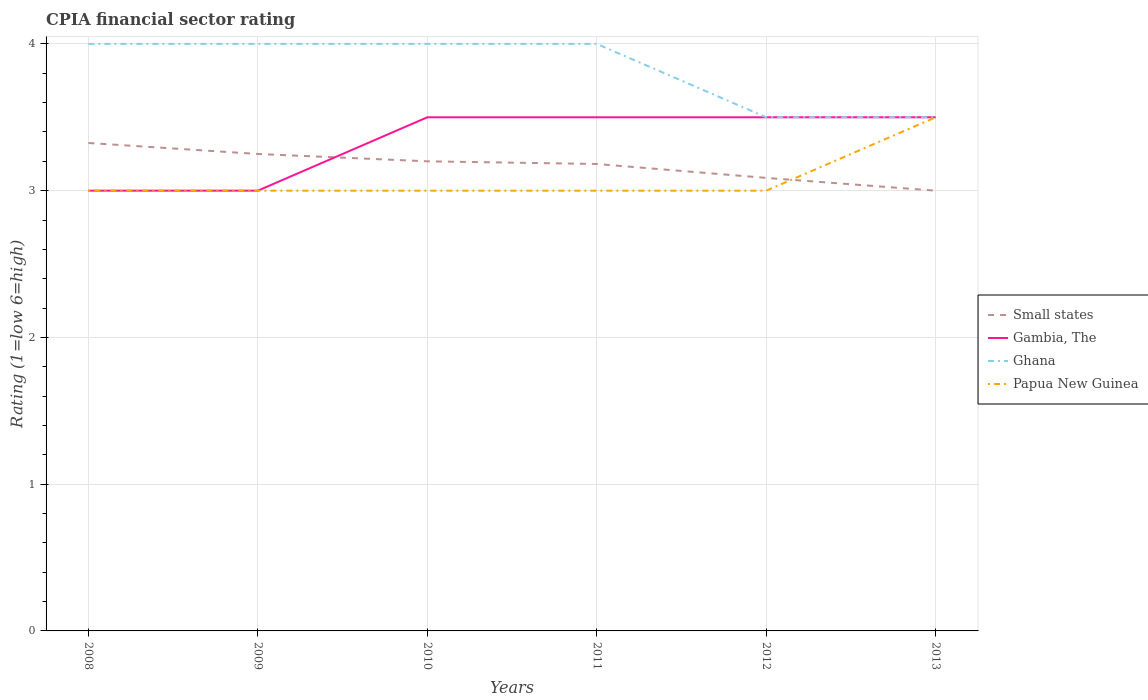Does the line corresponding to Small states intersect with the line corresponding to Gambia, The?
Offer a terse response. Yes. Across all years, what is the maximum CPIA rating in Ghana?
Your answer should be very brief. 3.5. In which year was the CPIA rating in Ghana maximum?
Your answer should be very brief. 2012. What is the difference between the highest and the second highest CPIA rating in Ghana?
Give a very brief answer. 0.5. How many lines are there?
Offer a terse response. 4. What is the difference between two consecutive major ticks on the Y-axis?
Provide a succinct answer. 1. Are the values on the major ticks of Y-axis written in scientific E-notation?
Ensure brevity in your answer.  No. Does the graph contain grids?
Provide a short and direct response. Yes. Where does the legend appear in the graph?
Make the answer very short. Center right. How many legend labels are there?
Make the answer very short. 4. How are the legend labels stacked?
Keep it short and to the point. Vertical. What is the title of the graph?
Offer a very short reply. CPIA financial sector rating. Does "Guam" appear as one of the legend labels in the graph?
Make the answer very short. No. What is the label or title of the X-axis?
Ensure brevity in your answer.  Years. What is the label or title of the Y-axis?
Your response must be concise. Rating (1=low 6=high). What is the Rating (1=low 6=high) of Small states in 2008?
Your answer should be compact. 3.33. What is the Rating (1=low 6=high) in Ghana in 2008?
Your answer should be compact. 4. What is the Rating (1=low 6=high) of Papua New Guinea in 2008?
Provide a succinct answer. 3. What is the Rating (1=low 6=high) of Small states in 2009?
Your answer should be very brief. 3.25. What is the Rating (1=low 6=high) in Papua New Guinea in 2009?
Make the answer very short. 3. What is the Rating (1=low 6=high) of Ghana in 2010?
Your response must be concise. 4. What is the Rating (1=low 6=high) of Papua New Guinea in 2010?
Keep it short and to the point. 3. What is the Rating (1=low 6=high) in Small states in 2011?
Give a very brief answer. 3.18. What is the Rating (1=low 6=high) of Ghana in 2011?
Provide a short and direct response. 4. What is the Rating (1=low 6=high) of Small states in 2012?
Make the answer very short. 3.09. What is the Rating (1=low 6=high) of Ghana in 2012?
Make the answer very short. 3.5. What is the Rating (1=low 6=high) of Small states in 2013?
Give a very brief answer. 3. What is the Rating (1=low 6=high) in Gambia, The in 2013?
Ensure brevity in your answer.  3.5. What is the Rating (1=low 6=high) of Ghana in 2013?
Ensure brevity in your answer.  3.5. What is the Rating (1=low 6=high) of Papua New Guinea in 2013?
Ensure brevity in your answer.  3.5. Across all years, what is the maximum Rating (1=low 6=high) of Small states?
Provide a succinct answer. 3.33. Across all years, what is the maximum Rating (1=low 6=high) of Gambia, The?
Keep it short and to the point. 3.5. Across all years, what is the maximum Rating (1=low 6=high) of Papua New Guinea?
Offer a terse response. 3.5. Across all years, what is the minimum Rating (1=low 6=high) in Gambia, The?
Offer a very short reply. 3. Across all years, what is the minimum Rating (1=low 6=high) of Ghana?
Provide a short and direct response. 3.5. What is the total Rating (1=low 6=high) of Small states in the graph?
Your answer should be compact. 19.04. What is the total Rating (1=low 6=high) of Papua New Guinea in the graph?
Offer a very short reply. 18.5. What is the difference between the Rating (1=low 6=high) in Small states in 2008 and that in 2009?
Provide a succinct answer. 0.07. What is the difference between the Rating (1=low 6=high) in Ghana in 2008 and that in 2009?
Keep it short and to the point. 0. What is the difference between the Rating (1=low 6=high) of Papua New Guinea in 2008 and that in 2009?
Provide a succinct answer. 0. What is the difference between the Rating (1=low 6=high) in Ghana in 2008 and that in 2010?
Provide a succinct answer. 0. What is the difference between the Rating (1=low 6=high) of Small states in 2008 and that in 2011?
Provide a succinct answer. 0.14. What is the difference between the Rating (1=low 6=high) in Gambia, The in 2008 and that in 2011?
Provide a short and direct response. -0.5. What is the difference between the Rating (1=low 6=high) of Small states in 2008 and that in 2012?
Your answer should be compact. 0.24. What is the difference between the Rating (1=low 6=high) of Gambia, The in 2008 and that in 2012?
Provide a succinct answer. -0.5. What is the difference between the Rating (1=low 6=high) in Small states in 2008 and that in 2013?
Keep it short and to the point. 0.33. What is the difference between the Rating (1=low 6=high) in Papua New Guinea in 2008 and that in 2013?
Offer a terse response. -0.5. What is the difference between the Rating (1=low 6=high) of Gambia, The in 2009 and that in 2010?
Make the answer very short. -0.5. What is the difference between the Rating (1=low 6=high) of Ghana in 2009 and that in 2010?
Ensure brevity in your answer.  0. What is the difference between the Rating (1=low 6=high) of Papua New Guinea in 2009 and that in 2010?
Your answer should be very brief. 0. What is the difference between the Rating (1=low 6=high) in Small states in 2009 and that in 2011?
Provide a succinct answer. 0.07. What is the difference between the Rating (1=low 6=high) in Gambia, The in 2009 and that in 2011?
Your answer should be compact. -0.5. What is the difference between the Rating (1=low 6=high) in Small states in 2009 and that in 2012?
Ensure brevity in your answer.  0.16. What is the difference between the Rating (1=low 6=high) in Gambia, The in 2009 and that in 2012?
Ensure brevity in your answer.  -0.5. What is the difference between the Rating (1=low 6=high) of Papua New Guinea in 2009 and that in 2012?
Your response must be concise. 0. What is the difference between the Rating (1=low 6=high) in Small states in 2009 and that in 2013?
Provide a short and direct response. 0.25. What is the difference between the Rating (1=low 6=high) in Ghana in 2009 and that in 2013?
Give a very brief answer. 0.5. What is the difference between the Rating (1=low 6=high) in Small states in 2010 and that in 2011?
Give a very brief answer. 0.02. What is the difference between the Rating (1=low 6=high) in Gambia, The in 2010 and that in 2011?
Your response must be concise. 0. What is the difference between the Rating (1=low 6=high) of Ghana in 2010 and that in 2011?
Your answer should be very brief. 0. What is the difference between the Rating (1=low 6=high) in Papua New Guinea in 2010 and that in 2011?
Give a very brief answer. 0. What is the difference between the Rating (1=low 6=high) of Small states in 2010 and that in 2012?
Provide a short and direct response. 0.11. What is the difference between the Rating (1=low 6=high) of Ghana in 2010 and that in 2012?
Offer a terse response. 0.5. What is the difference between the Rating (1=low 6=high) in Papua New Guinea in 2010 and that in 2012?
Your answer should be compact. 0. What is the difference between the Rating (1=low 6=high) in Ghana in 2010 and that in 2013?
Keep it short and to the point. 0.5. What is the difference between the Rating (1=low 6=high) in Papua New Guinea in 2010 and that in 2013?
Provide a succinct answer. -0.5. What is the difference between the Rating (1=low 6=high) of Small states in 2011 and that in 2012?
Keep it short and to the point. 0.09. What is the difference between the Rating (1=low 6=high) of Papua New Guinea in 2011 and that in 2012?
Your answer should be very brief. 0. What is the difference between the Rating (1=low 6=high) in Small states in 2011 and that in 2013?
Give a very brief answer. 0.18. What is the difference between the Rating (1=low 6=high) of Gambia, The in 2011 and that in 2013?
Your answer should be very brief. 0. What is the difference between the Rating (1=low 6=high) in Ghana in 2011 and that in 2013?
Your answer should be very brief. 0.5. What is the difference between the Rating (1=low 6=high) of Papua New Guinea in 2011 and that in 2013?
Give a very brief answer. -0.5. What is the difference between the Rating (1=low 6=high) in Small states in 2012 and that in 2013?
Give a very brief answer. 0.09. What is the difference between the Rating (1=low 6=high) in Ghana in 2012 and that in 2013?
Your response must be concise. 0. What is the difference between the Rating (1=low 6=high) of Small states in 2008 and the Rating (1=low 6=high) of Gambia, The in 2009?
Offer a very short reply. 0.33. What is the difference between the Rating (1=low 6=high) of Small states in 2008 and the Rating (1=low 6=high) of Ghana in 2009?
Your answer should be very brief. -0.68. What is the difference between the Rating (1=low 6=high) in Small states in 2008 and the Rating (1=low 6=high) in Papua New Guinea in 2009?
Make the answer very short. 0.33. What is the difference between the Rating (1=low 6=high) in Gambia, The in 2008 and the Rating (1=low 6=high) in Ghana in 2009?
Your answer should be compact. -1. What is the difference between the Rating (1=low 6=high) in Small states in 2008 and the Rating (1=low 6=high) in Gambia, The in 2010?
Keep it short and to the point. -0.17. What is the difference between the Rating (1=low 6=high) in Small states in 2008 and the Rating (1=low 6=high) in Ghana in 2010?
Provide a succinct answer. -0.68. What is the difference between the Rating (1=low 6=high) in Small states in 2008 and the Rating (1=low 6=high) in Papua New Guinea in 2010?
Your response must be concise. 0.33. What is the difference between the Rating (1=low 6=high) in Gambia, The in 2008 and the Rating (1=low 6=high) in Papua New Guinea in 2010?
Offer a very short reply. 0. What is the difference between the Rating (1=low 6=high) in Small states in 2008 and the Rating (1=low 6=high) in Gambia, The in 2011?
Your response must be concise. -0.17. What is the difference between the Rating (1=low 6=high) of Small states in 2008 and the Rating (1=low 6=high) of Ghana in 2011?
Keep it short and to the point. -0.68. What is the difference between the Rating (1=low 6=high) of Small states in 2008 and the Rating (1=low 6=high) of Papua New Guinea in 2011?
Keep it short and to the point. 0.33. What is the difference between the Rating (1=low 6=high) of Small states in 2008 and the Rating (1=low 6=high) of Gambia, The in 2012?
Your answer should be compact. -0.17. What is the difference between the Rating (1=low 6=high) in Small states in 2008 and the Rating (1=low 6=high) in Ghana in 2012?
Your response must be concise. -0.17. What is the difference between the Rating (1=low 6=high) of Small states in 2008 and the Rating (1=low 6=high) of Papua New Guinea in 2012?
Ensure brevity in your answer.  0.33. What is the difference between the Rating (1=low 6=high) of Gambia, The in 2008 and the Rating (1=low 6=high) of Ghana in 2012?
Your answer should be very brief. -0.5. What is the difference between the Rating (1=low 6=high) in Ghana in 2008 and the Rating (1=low 6=high) in Papua New Guinea in 2012?
Make the answer very short. 1. What is the difference between the Rating (1=low 6=high) in Small states in 2008 and the Rating (1=low 6=high) in Gambia, The in 2013?
Keep it short and to the point. -0.17. What is the difference between the Rating (1=low 6=high) of Small states in 2008 and the Rating (1=low 6=high) of Ghana in 2013?
Offer a terse response. -0.17. What is the difference between the Rating (1=low 6=high) in Small states in 2008 and the Rating (1=low 6=high) in Papua New Guinea in 2013?
Your answer should be compact. -0.17. What is the difference between the Rating (1=low 6=high) of Gambia, The in 2008 and the Rating (1=low 6=high) of Ghana in 2013?
Offer a very short reply. -0.5. What is the difference between the Rating (1=low 6=high) of Gambia, The in 2008 and the Rating (1=low 6=high) of Papua New Guinea in 2013?
Offer a very short reply. -0.5. What is the difference between the Rating (1=low 6=high) of Ghana in 2008 and the Rating (1=low 6=high) of Papua New Guinea in 2013?
Keep it short and to the point. 0.5. What is the difference between the Rating (1=low 6=high) in Small states in 2009 and the Rating (1=low 6=high) in Gambia, The in 2010?
Make the answer very short. -0.25. What is the difference between the Rating (1=low 6=high) in Small states in 2009 and the Rating (1=low 6=high) in Ghana in 2010?
Your answer should be very brief. -0.75. What is the difference between the Rating (1=low 6=high) of Gambia, The in 2009 and the Rating (1=low 6=high) of Ghana in 2010?
Provide a short and direct response. -1. What is the difference between the Rating (1=low 6=high) in Small states in 2009 and the Rating (1=low 6=high) in Gambia, The in 2011?
Give a very brief answer. -0.25. What is the difference between the Rating (1=low 6=high) in Small states in 2009 and the Rating (1=low 6=high) in Ghana in 2011?
Make the answer very short. -0.75. What is the difference between the Rating (1=low 6=high) of Gambia, The in 2009 and the Rating (1=low 6=high) of Papua New Guinea in 2011?
Make the answer very short. 0. What is the difference between the Rating (1=low 6=high) of Small states in 2009 and the Rating (1=low 6=high) of Gambia, The in 2012?
Offer a terse response. -0.25. What is the difference between the Rating (1=low 6=high) in Small states in 2009 and the Rating (1=low 6=high) in Ghana in 2012?
Provide a succinct answer. -0.25. What is the difference between the Rating (1=low 6=high) in Ghana in 2009 and the Rating (1=low 6=high) in Papua New Guinea in 2012?
Ensure brevity in your answer.  1. What is the difference between the Rating (1=low 6=high) of Small states in 2009 and the Rating (1=low 6=high) of Gambia, The in 2013?
Provide a succinct answer. -0.25. What is the difference between the Rating (1=low 6=high) of Small states in 2009 and the Rating (1=low 6=high) of Ghana in 2013?
Make the answer very short. -0.25. What is the difference between the Rating (1=low 6=high) in Gambia, The in 2009 and the Rating (1=low 6=high) in Ghana in 2013?
Keep it short and to the point. -0.5. What is the difference between the Rating (1=low 6=high) in Small states in 2010 and the Rating (1=low 6=high) in Ghana in 2011?
Make the answer very short. -0.8. What is the difference between the Rating (1=low 6=high) of Ghana in 2010 and the Rating (1=low 6=high) of Papua New Guinea in 2011?
Keep it short and to the point. 1. What is the difference between the Rating (1=low 6=high) in Small states in 2010 and the Rating (1=low 6=high) in Gambia, The in 2012?
Make the answer very short. -0.3. What is the difference between the Rating (1=low 6=high) of Gambia, The in 2010 and the Rating (1=low 6=high) of Papua New Guinea in 2012?
Make the answer very short. 0.5. What is the difference between the Rating (1=low 6=high) in Small states in 2010 and the Rating (1=low 6=high) in Gambia, The in 2013?
Provide a short and direct response. -0.3. What is the difference between the Rating (1=low 6=high) in Small states in 2010 and the Rating (1=low 6=high) in Papua New Guinea in 2013?
Offer a terse response. -0.3. What is the difference between the Rating (1=low 6=high) in Gambia, The in 2010 and the Rating (1=low 6=high) in Ghana in 2013?
Provide a short and direct response. 0. What is the difference between the Rating (1=low 6=high) in Small states in 2011 and the Rating (1=low 6=high) in Gambia, The in 2012?
Your answer should be very brief. -0.32. What is the difference between the Rating (1=low 6=high) of Small states in 2011 and the Rating (1=low 6=high) of Ghana in 2012?
Keep it short and to the point. -0.32. What is the difference between the Rating (1=low 6=high) in Small states in 2011 and the Rating (1=low 6=high) in Papua New Guinea in 2012?
Keep it short and to the point. 0.18. What is the difference between the Rating (1=low 6=high) in Gambia, The in 2011 and the Rating (1=low 6=high) in Ghana in 2012?
Your answer should be compact. 0. What is the difference between the Rating (1=low 6=high) of Ghana in 2011 and the Rating (1=low 6=high) of Papua New Guinea in 2012?
Your answer should be compact. 1. What is the difference between the Rating (1=low 6=high) of Small states in 2011 and the Rating (1=low 6=high) of Gambia, The in 2013?
Provide a short and direct response. -0.32. What is the difference between the Rating (1=low 6=high) in Small states in 2011 and the Rating (1=low 6=high) in Ghana in 2013?
Keep it short and to the point. -0.32. What is the difference between the Rating (1=low 6=high) of Small states in 2011 and the Rating (1=low 6=high) of Papua New Guinea in 2013?
Your answer should be compact. -0.32. What is the difference between the Rating (1=low 6=high) of Gambia, The in 2011 and the Rating (1=low 6=high) of Ghana in 2013?
Give a very brief answer. 0. What is the difference between the Rating (1=low 6=high) of Small states in 2012 and the Rating (1=low 6=high) of Gambia, The in 2013?
Make the answer very short. -0.41. What is the difference between the Rating (1=low 6=high) in Small states in 2012 and the Rating (1=low 6=high) in Ghana in 2013?
Provide a short and direct response. -0.41. What is the difference between the Rating (1=low 6=high) in Small states in 2012 and the Rating (1=low 6=high) in Papua New Guinea in 2013?
Your answer should be compact. -0.41. What is the difference between the Rating (1=low 6=high) of Ghana in 2012 and the Rating (1=low 6=high) of Papua New Guinea in 2013?
Offer a terse response. 0. What is the average Rating (1=low 6=high) in Small states per year?
Give a very brief answer. 3.17. What is the average Rating (1=low 6=high) in Gambia, The per year?
Your response must be concise. 3.33. What is the average Rating (1=low 6=high) of Ghana per year?
Your answer should be very brief. 3.83. What is the average Rating (1=low 6=high) in Papua New Guinea per year?
Provide a succinct answer. 3.08. In the year 2008, what is the difference between the Rating (1=low 6=high) of Small states and Rating (1=low 6=high) of Gambia, The?
Give a very brief answer. 0.33. In the year 2008, what is the difference between the Rating (1=low 6=high) in Small states and Rating (1=low 6=high) in Ghana?
Keep it short and to the point. -0.68. In the year 2008, what is the difference between the Rating (1=low 6=high) of Small states and Rating (1=low 6=high) of Papua New Guinea?
Keep it short and to the point. 0.33. In the year 2008, what is the difference between the Rating (1=low 6=high) of Gambia, The and Rating (1=low 6=high) of Ghana?
Your answer should be very brief. -1. In the year 2008, what is the difference between the Rating (1=low 6=high) of Ghana and Rating (1=low 6=high) of Papua New Guinea?
Provide a succinct answer. 1. In the year 2009, what is the difference between the Rating (1=low 6=high) in Small states and Rating (1=low 6=high) in Ghana?
Provide a short and direct response. -0.75. In the year 2009, what is the difference between the Rating (1=low 6=high) of Small states and Rating (1=low 6=high) of Papua New Guinea?
Provide a succinct answer. 0.25. In the year 2009, what is the difference between the Rating (1=low 6=high) in Gambia, The and Rating (1=low 6=high) in Papua New Guinea?
Your response must be concise. 0. In the year 2009, what is the difference between the Rating (1=low 6=high) of Ghana and Rating (1=low 6=high) of Papua New Guinea?
Make the answer very short. 1. In the year 2010, what is the difference between the Rating (1=low 6=high) in Small states and Rating (1=low 6=high) in Gambia, The?
Your answer should be compact. -0.3. In the year 2010, what is the difference between the Rating (1=low 6=high) of Small states and Rating (1=low 6=high) of Ghana?
Offer a terse response. -0.8. In the year 2010, what is the difference between the Rating (1=low 6=high) of Gambia, The and Rating (1=low 6=high) of Ghana?
Provide a succinct answer. -0.5. In the year 2010, what is the difference between the Rating (1=low 6=high) of Gambia, The and Rating (1=low 6=high) of Papua New Guinea?
Offer a terse response. 0.5. In the year 2011, what is the difference between the Rating (1=low 6=high) in Small states and Rating (1=low 6=high) in Gambia, The?
Give a very brief answer. -0.32. In the year 2011, what is the difference between the Rating (1=low 6=high) in Small states and Rating (1=low 6=high) in Ghana?
Your answer should be very brief. -0.82. In the year 2011, what is the difference between the Rating (1=low 6=high) in Small states and Rating (1=low 6=high) in Papua New Guinea?
Give a very brief answer. 0.18. In the year 2011, what is the difference between the Rating (1=low 6=high) of Gambia, The and Rating (1=low 6=high) of Ghana?
Provide a succinct answer. -0.5. In the year 2011, what is the difference between the Rating (1=low 6=high) of Gambia, The and Rating (1=low 6=high) of Papua New Guinea?
Your answer should be compact. 0.5. In the year 2012, what is the difference between the Rating (1=low 6=high) in Small states and Rating (1=low 6=high) in Gambia, The?
Keep it short and to the point. -0.41. In the year 2012, what is the difference between the Rating (1=low 6=high) in Small states and Rating (1=low 6=high) in Ghana?
Offer a terse response. -0.41. In the year 2012, what is the difference between the Rating (1=low 6=high) in Small states and Rating (1=low 6=high) in Papua New Guinea?
Your answer should be compact. 0.09. In the year 2012, what is the difference between the Rating (1=low 6=high) in Ghana and Rating (1=low 6=high) in Papua New Guinea?
Ensure brevity in your answer.  0.5. In the year 2013, what is the difference between the Rating (1=low 6=high) of Small states and Rating (1=low 6=high) of Papua New Guinea?
Provide a succinct answer. -0.5. In the year 2013, what is the difference between the Rating (1=low 6=high) of Ghana and Rating (1=low 6=high) of Papua New Guinea?
Make the answer very short. 0. What is the ratio of the Rating (1=low 6=high) of Small states in 2008 to that in 2009?
Offer a very short reply. 1.02. What is the ratio of the Rating (1=low 6=high) in Ghana in 2008 to that in 2009?
Provide a short and direct response. 1. What is the ratio of the Rating (1=low 6=high) in Papua New Guinea in 2008 to that in 2009?
Keep it short and to the point. 1. What is the ratio of the Rating (1=low 6=high) of Small states in 2008 to that in 2010?
Provide a short and direct response. 1.04. What is the ratio of the Rating (1=low 6=high) of Gambia, The in 2008 to that in 2010?
Keep it short and to the point. 0.86. What is the ratio of the Rating (1=low 6=high) in Ghana in 2008 to that in 2010?
Give a very brief answer. 1. What is the ratio of the Rating (1=low 6=high) of Papua New Guinea in 2008 to that in 2010?
Provide a short and direct response. 1. What is the ratio of the Rating (1=low 6=high) in Small states in 2008 to that in 2011?
Give a very brief answer. 1.04. What is the ratio of the Rating (1=low 6=high) of Gambia, The in 2008 to that in 2011?
Keep it short and to the point. 0.86. What is the ratio of the Rating (1=low 6=high) of Ghana in 2008 to that in 2011?
Offer a very short reply. 1. What is the ratio of the Rating (1=low 6=high) of Small states in 2008 to that in 2012?
Your answer should be compact. 1.08. What is the ratio of the Rating (1=low 6=high) in Gambia, The in 2008 to that in 2012?
Provide a succinct answer. 0.86. What is the ratio of the Rating (1=low 6=high) of Ghana in 2008 to that in 2012?
Your answer should be very brief. 1.14. What is the ratio of the Rating (1=low 6=high) of Papua New Guinea in 2008 to that in 2012?
Ensure brevity in your answer.  1. What is the ratio of the Rating (1=low 6=high) in Small states in 2008 to that in 2013?
Offer a terse response. 1.11. What is the ratio of the Rating (1=low 6=high) in Gambia, The in 2008 to that in 2013?
Make the answer very short. 0.86. What is the ratio of the Rating (1=low 6=high) in Ghana in 2008 to that in 2013?
Offer a very short reply. 1.14. What is the ratio of the Rating (1=low 6=high) in Papua New Guinea in 2008 to that in 2013?
Give a very brief answer. 0.86. What is the ratio of the Rating (1=low 6=high) in Small states in 2009 to that in 2010?
Ensure brevity in your answer.  1.02. What is the ratio of the Rating (1=low 6=high) of Gambia, The in 2009 to that in 2010?
Provide a short and direct response. 0.86. What is the ratio of the Rating (1=low 6=high) in Ghana in 2009 to that in 2010?
Your answer should be compact. 1. What is the ratio of the Rating (1=low 6=high) in Papua New Guinea in 2009 to that in 2010?
Your answer should be very brief. 1. What is the ratio of the Rating (1=low 6=high) in Small states in 2009 to that in 2011?
Ensure brevity in your answer.  1.02. What is the ratio of the Rating (1=low 6=high) in Gambia, The in 2009 to that in 2011?
Ensure brevity in your answer.  0.86. What is the ratio of the Rating (1=low 6=high) of Small states in 2009 to that in 2012?
Offer a terse response. 1.05. What is the ratio of the Rating (1=low 6=high) in Gambia, The in 2009 to that in 2012?
Your answer should be compact. 0.86. What is the ratio of the Rating (1=low 6=high) in Papua New Guinea in 2009 to that in 2012?
Your response must be concise. 1. What is the ratio of the Rating (1=low 6=high) of Ghana in 2009 to that in 2013?
Give a very brief answer. 1.14. What is the ratio of the Rating (1=low 6=high) of Small states in 2010 to that in 2011?
Ensure brevity in your answer.  1.01. What is the ratio of the Rating (1=low 6=high) of Gambia, The in 2010 to that in 2011?
Your answer should be very brief. 1. What is the ratio of the Rating (1=low 6=high) of Ghana in 2010 to that in 2011?
Your response must be concise. 1. What is the ratio of the Rating (1=low 6=high) in Small states in 2010 to that in 2012?
Provide a succinct answer. 1.04. What is the ratio of the Rating (1=low 6=high) in Gambia, The in 2010 to that in 2012?
Make the answer very short. 1. What is the ratio of the Rating (1=low 6=high) of Papua New Guinea in 2010 to that in 2012?
Your answer should be compact. 1. What is the ratio of the Rating (1=low 6=high) of Small states in 2010 to that in 2013?
Your answer should be compact. 1.07. What is the ratio of the Rating (1=low 6=high) in Gambia, The in 2010 to that in 2013?
Provide a short and direct response. 1. What is the ratio of the Rating (1=low 6=high) of Papua New Guinea in 2010 to that in 2013?
Your answer should be compact. 0.86. What is the ratio of the Rating (1=low 6=high) of Small states in 2011 to that in 2012?
Provide a short and direct response. 1.03. What is the ratio of the Rating (1=low 6=high) in Small states in 2011 to that in 2013?
Offer a very short reply. 1.06. What is the ratio of the Rating (1=low 6=high) of Ghana in 2011 to that in 2013?
Offer a very short reply. 1.14. What is the ratio of the Rating (1=low 6=high) of Papua New Guinea in 2011 to that in 2013?
Offer a very short reply. 0.86. What is the ratio of the Rating (1=low 6=high) of Small states in 2012 to that in 2013?
Give a very brief answer. 1.03. What is the ratio of the Rating (1=low 6=high) in Ghana in 2012 to that in 2013?
Provide a short and direct response. 1. What is the difference between the highest and the second highest Rating (1=low 6=high) of Small states?
Offer a terse response. 0.07. What is the difference between the highest and the second highest Rating (1=low 6=high) of Gambia, The?
Your answer should be very brief. 0. What is the difference between the highest and the second highest Rating (1=low 6=high) in Ghana?
Your answer should be compact. 0. What is the difference between the highest and the second highest Rating (1=low 6=high) in Papua New Guinea?
Provide a short and direct response. 0.5. What is the difference between the highest and the lowest Rating (1=low 6=high) in Small states?
Provide a succinct answer. 0.33. What is the difference between the highest and the lowest Rating (1=low 6=high) in Papua New Guinea?
Your answer should be compact. 0.5. 